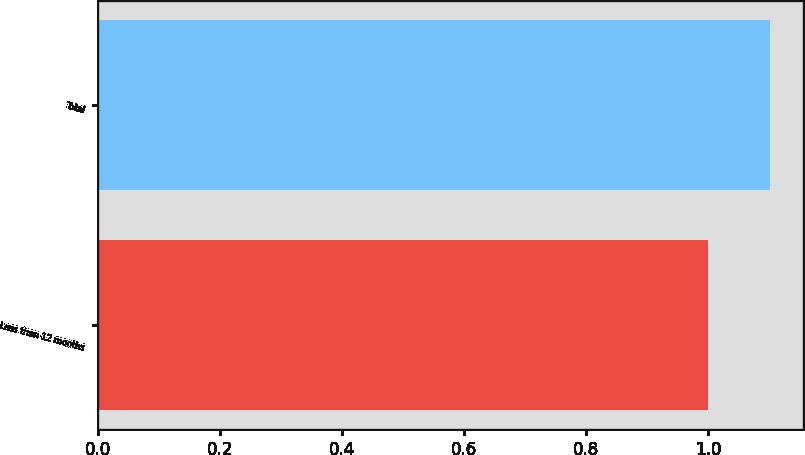Convert chart to OTSL. <chart><loc_0><loc_0><loc_500><loc_500><bar_chart><fcel>Less than 12 months<fcel>Total<nl><fcel>1<fcel>1.1<nl></chart> 